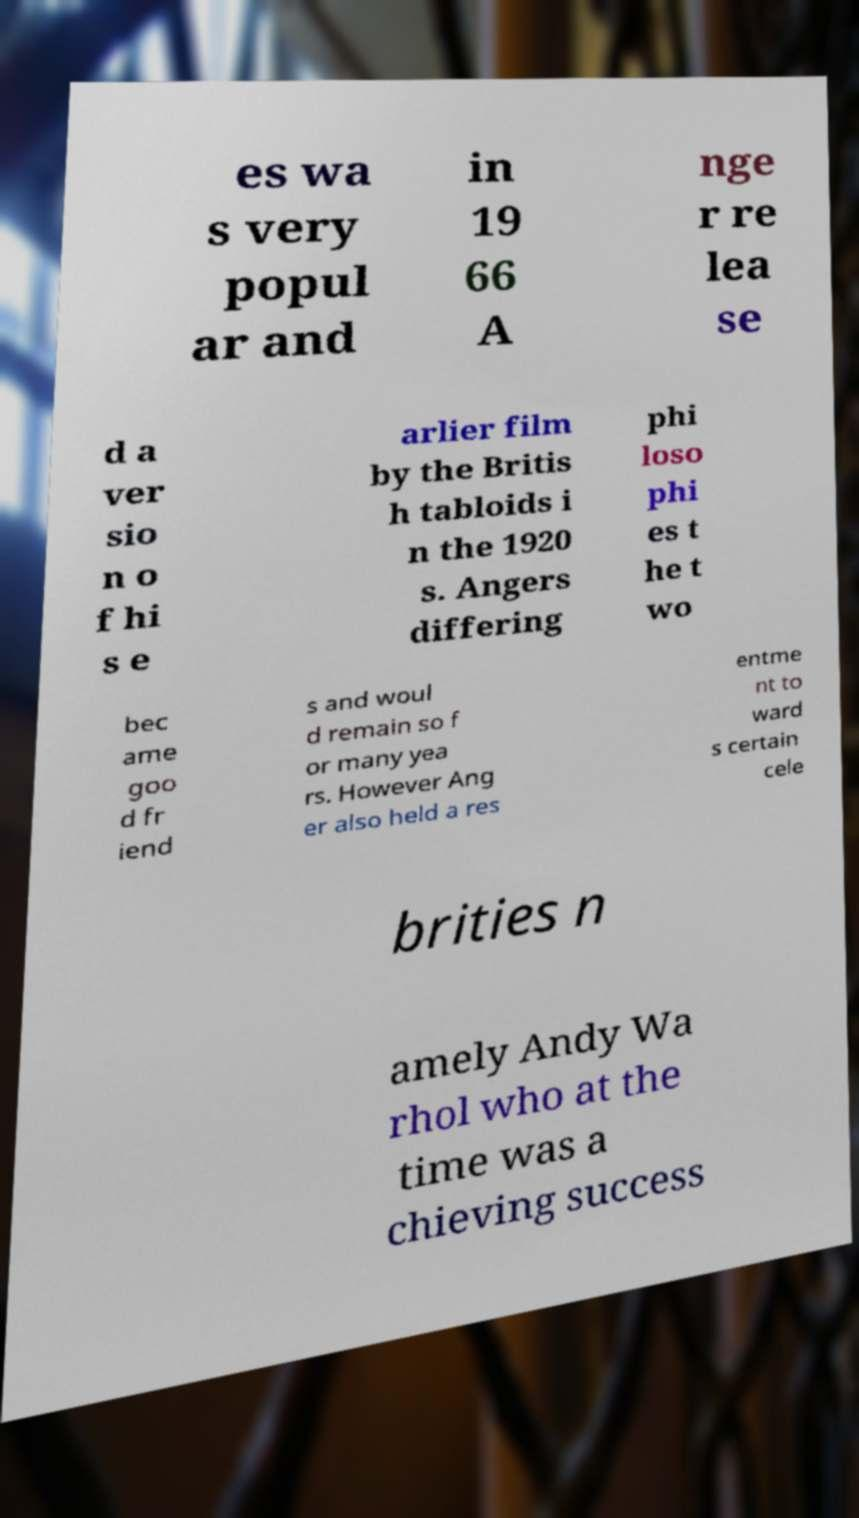For documentation purposes, I need the text within this image transcribed. Could you provide that? es wa s very popul ar and in 19 66 A nge r re lea se d a ver sio n o f hi s e arlier film by the Britis h tabloids i n the 1920 s. Angers differing phi loso phi es t he t wo bec ame goo d fr iend s and woul d remain so f or many yea rs. However Ang er also held a res entme nt to ward s certain cele brities n amely Andy Wa rhol who at the time was a chieving success 